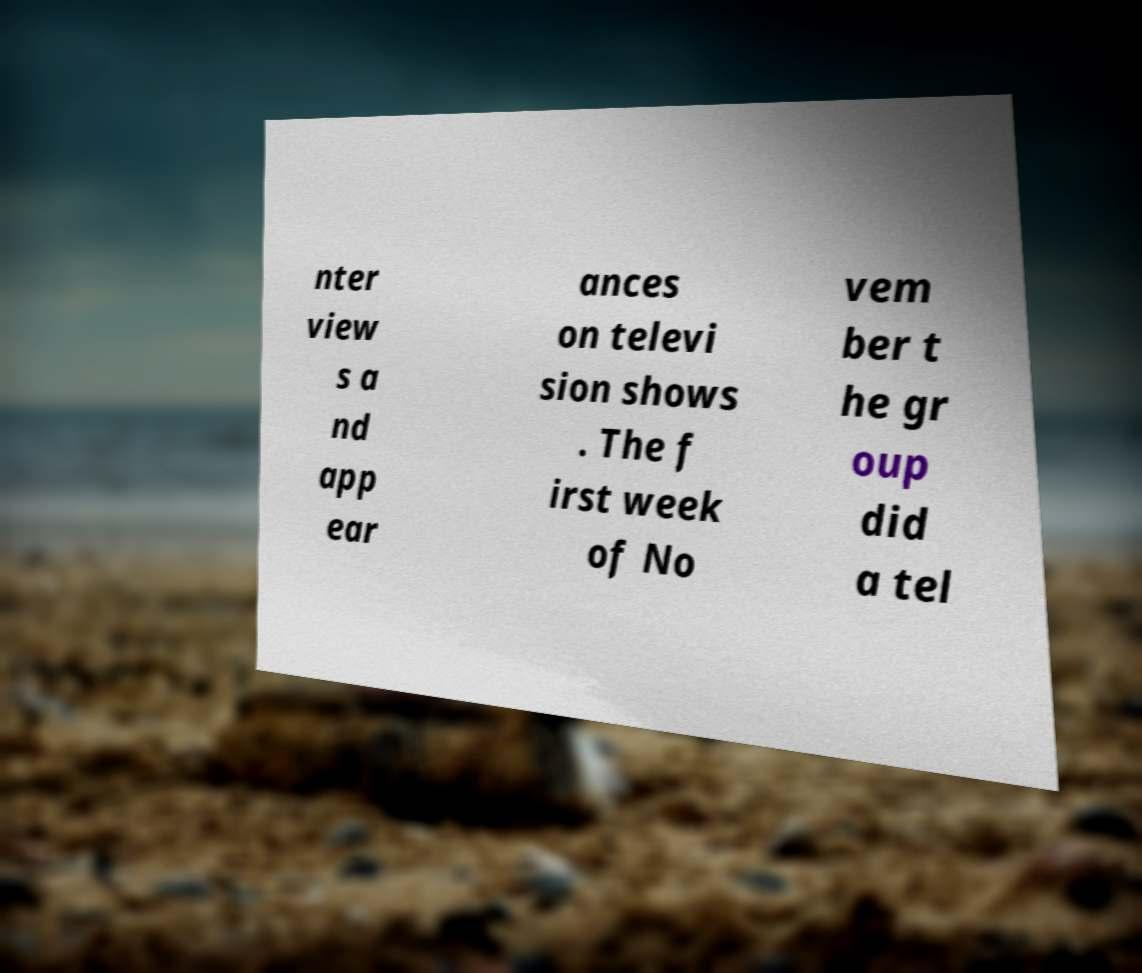Could you extract and type out the text from this image? nter view s a nd app ear ances on televi sion shows . The f irst week of No vem ber t he gr oup did a tel 